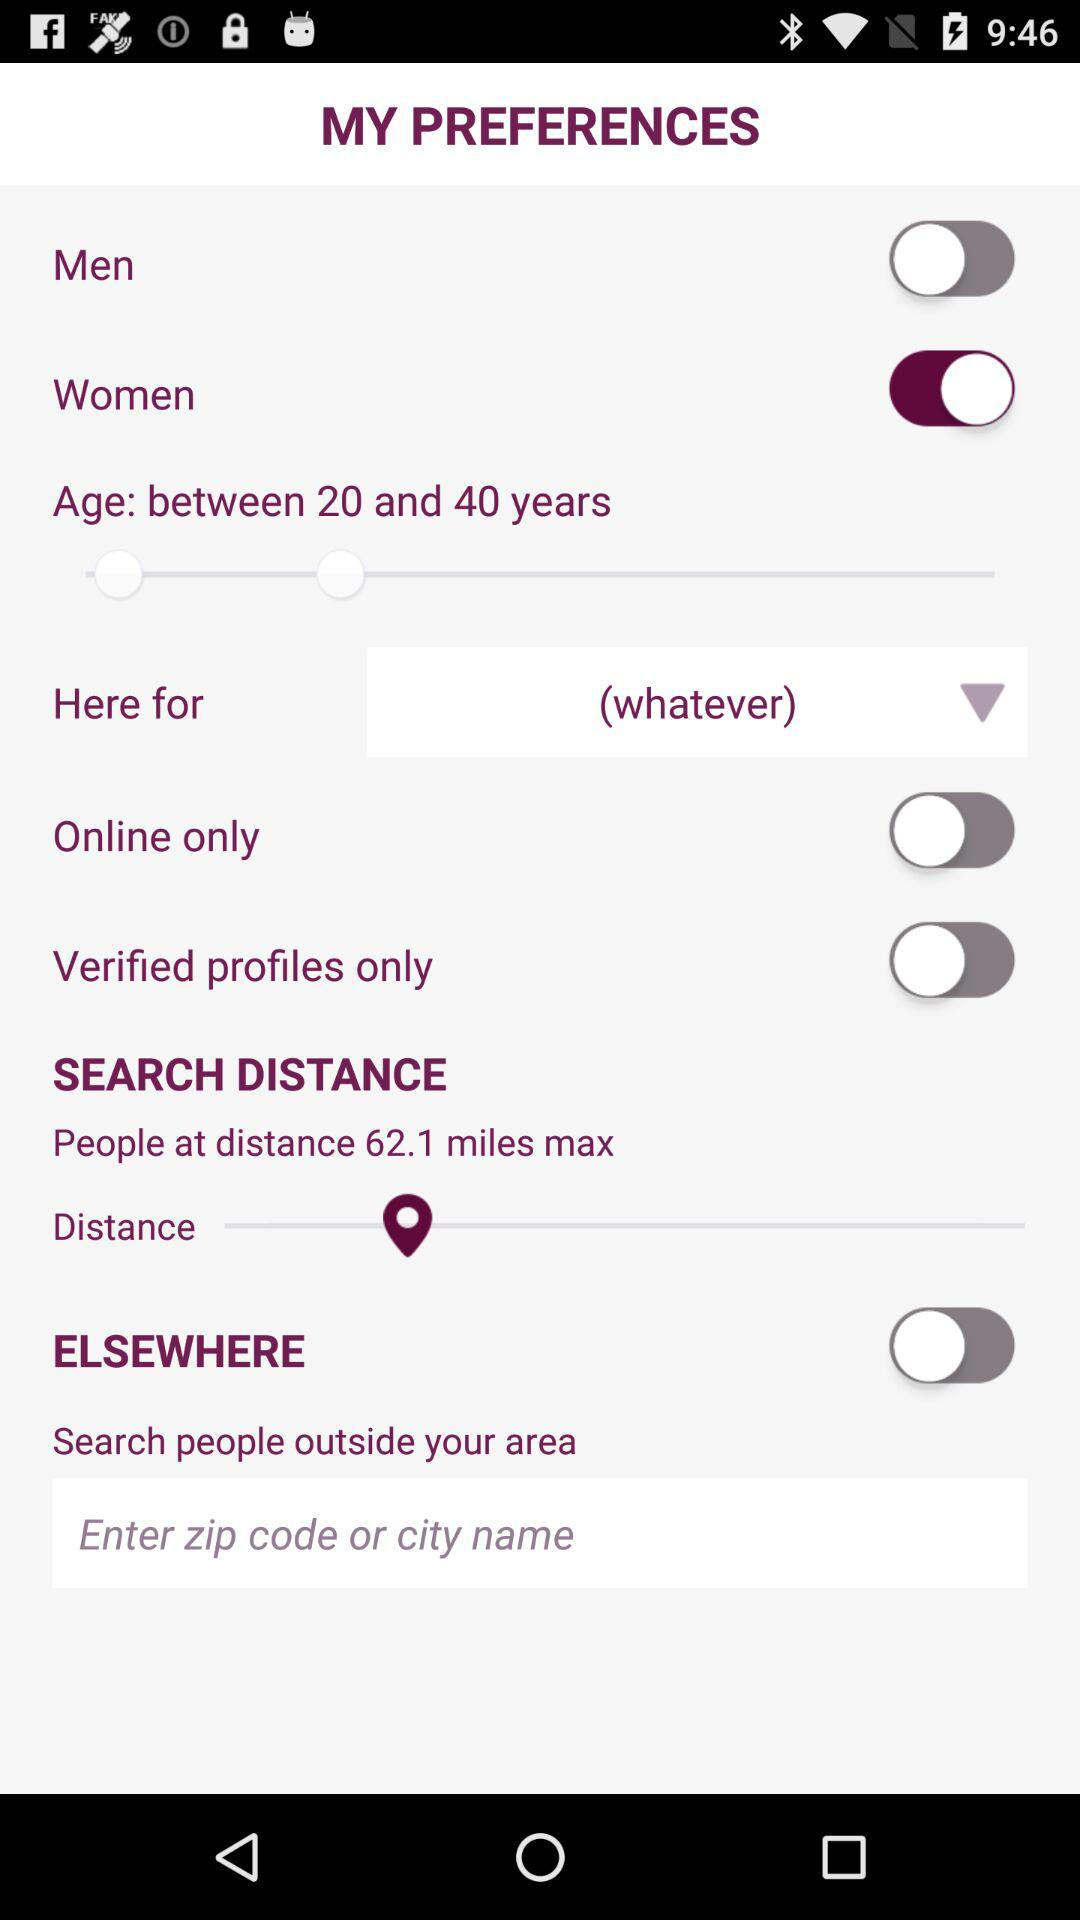What is the status of the Elsewhere? The status is off. 